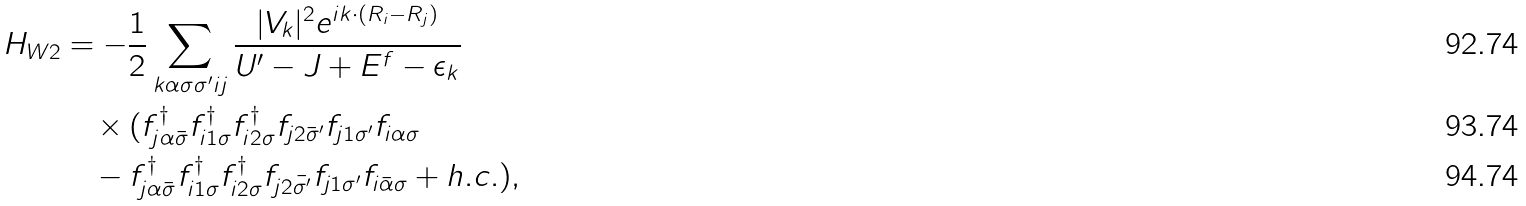<formula> <loc_0><loc_0><loc_500><loc_500>H _ { W 2 } & = - \frac { 1 } { 2 } \sum _ { { k } \alpha \sigma \sigma ^ { \prime } i j } \frac { | V _ { k } | ^ { 2 } e ^ { i { k } \cdot ( { R } _ { i } - { R } _ { j } ) } } { U ^ { \prime } - J + E ^ { f } - \epsilon _ { k } } \\ & \quad \times ( f ^ { \dagger } _ { j \alpha \bar { \sigma } } f ^ { \dagger } _ { i 1 \sigma } f ^ { \dagger } _ { i 2 \sigma } f _ { j 2 \bar { \sigma } ^ { \prime } } f _ { j 1 \sigma ^ { \prime } } f _ { i \alpha \sigma } \\ & \quad - f ^ { \dagger } _ { j \alpha \bar { \sigma } } f ^ { \dagger } _ { i 1 \sigma } f ^ { \dagger } _ { i 2 \sigma } f _ { j 2 \bar { \sigma ^ { \prime } } } f _ { j 1 \sigma ^ { \prime } } f _ { i \bar { \alpha } \sigma } + h . c . ) ,</formula> 